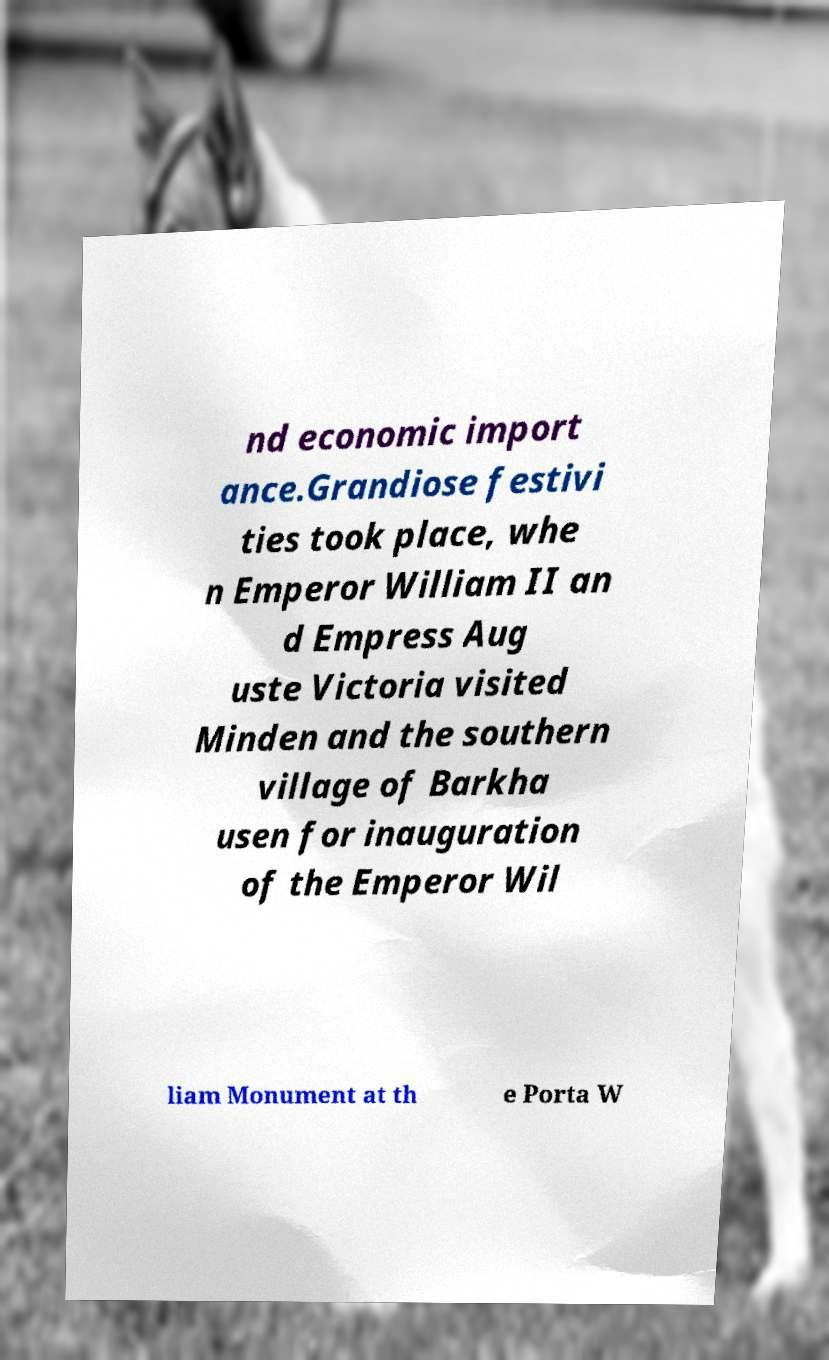I need the written content from this picture converted into text. Can you do that? nd economic import ance.Grandiose festivi ties took place, whe n Emperor William II an d Empress Aug uste Victoria visited Minden and the southern village of Barkha usen for inauguration of the Emperor Wil liam Monument at th e Porta W 